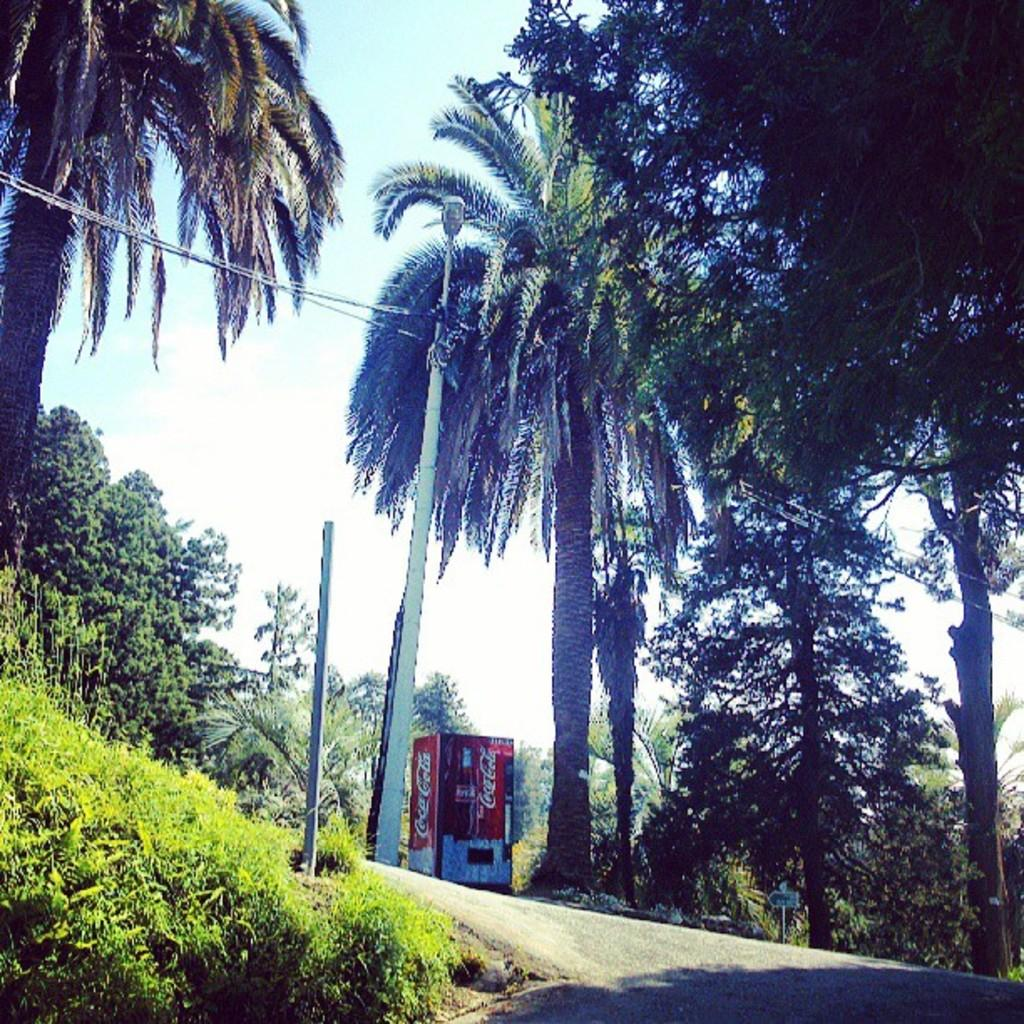What type of vegetation is present in the image? There is grass and trees in the image. What structure can be seen in the image? There is a vending machine in the image. What part of the natural environment is visible in the image? The sky is visible in the image. How many weeks does the body of water last in the image? There is no body of water present in the image. What type of edge can be seen on the grass in the image? There is no specific edge mentioned on the grass in the image. 